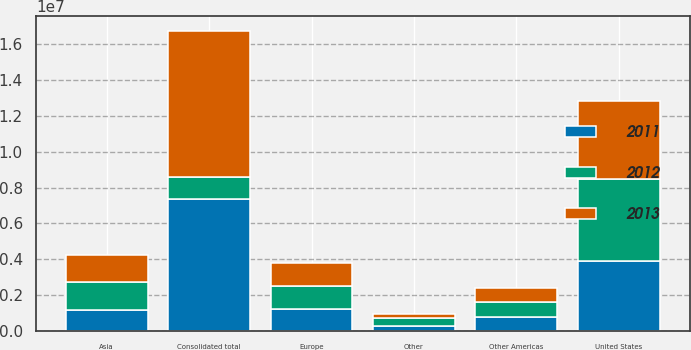Convert chart to OTSL. <chart><loc_0><loc_0><loc_500><loc_500><stacked_bar_chart><ecel><fcel>United States<fcel>Europe<fcel>Other Americas<fcel>Asia<fcel>Other<fcel>Consolidated total<nl><fcel>2012<fcel>4.56296e+06<fcel>1.28092e+06<fcel>852559<fcel>1.57789e+06<fcel>455487<fcel>1.24704e+06<nl><fcel>2013<fcel>4.34395e+06<fcel>1.24022e+06<fcel>793556<fcel>1.48825e+06<fcel>238364<fcel>8.10434e+06<nl><fcel>2011<fcel>3.92312e+06<fcel>1.24704e+06<fcel>771239<fcel>1.1621e+06<fcel>265655<fcel>7.36915e+06<nl></chart> 